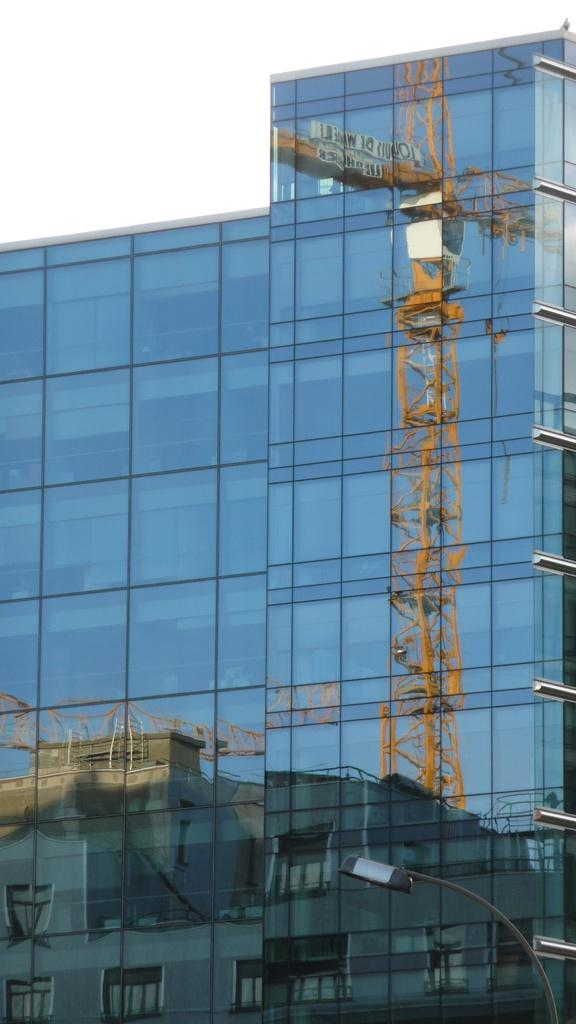What type of building is depicted in the image? There is a glass building in the image. What can be seen reflected in the glass building? The glass building reflects a tower crane and another building. Where is the pole with a light located in the image? The pole with a light is in the bottom right corner of the image. How many children are playing in the image? There are no children present in the image. What type of attention is the glass building receiving in the image? The glass building is not receiving any specific type of attention in the image; it is simply a building with reflections. 